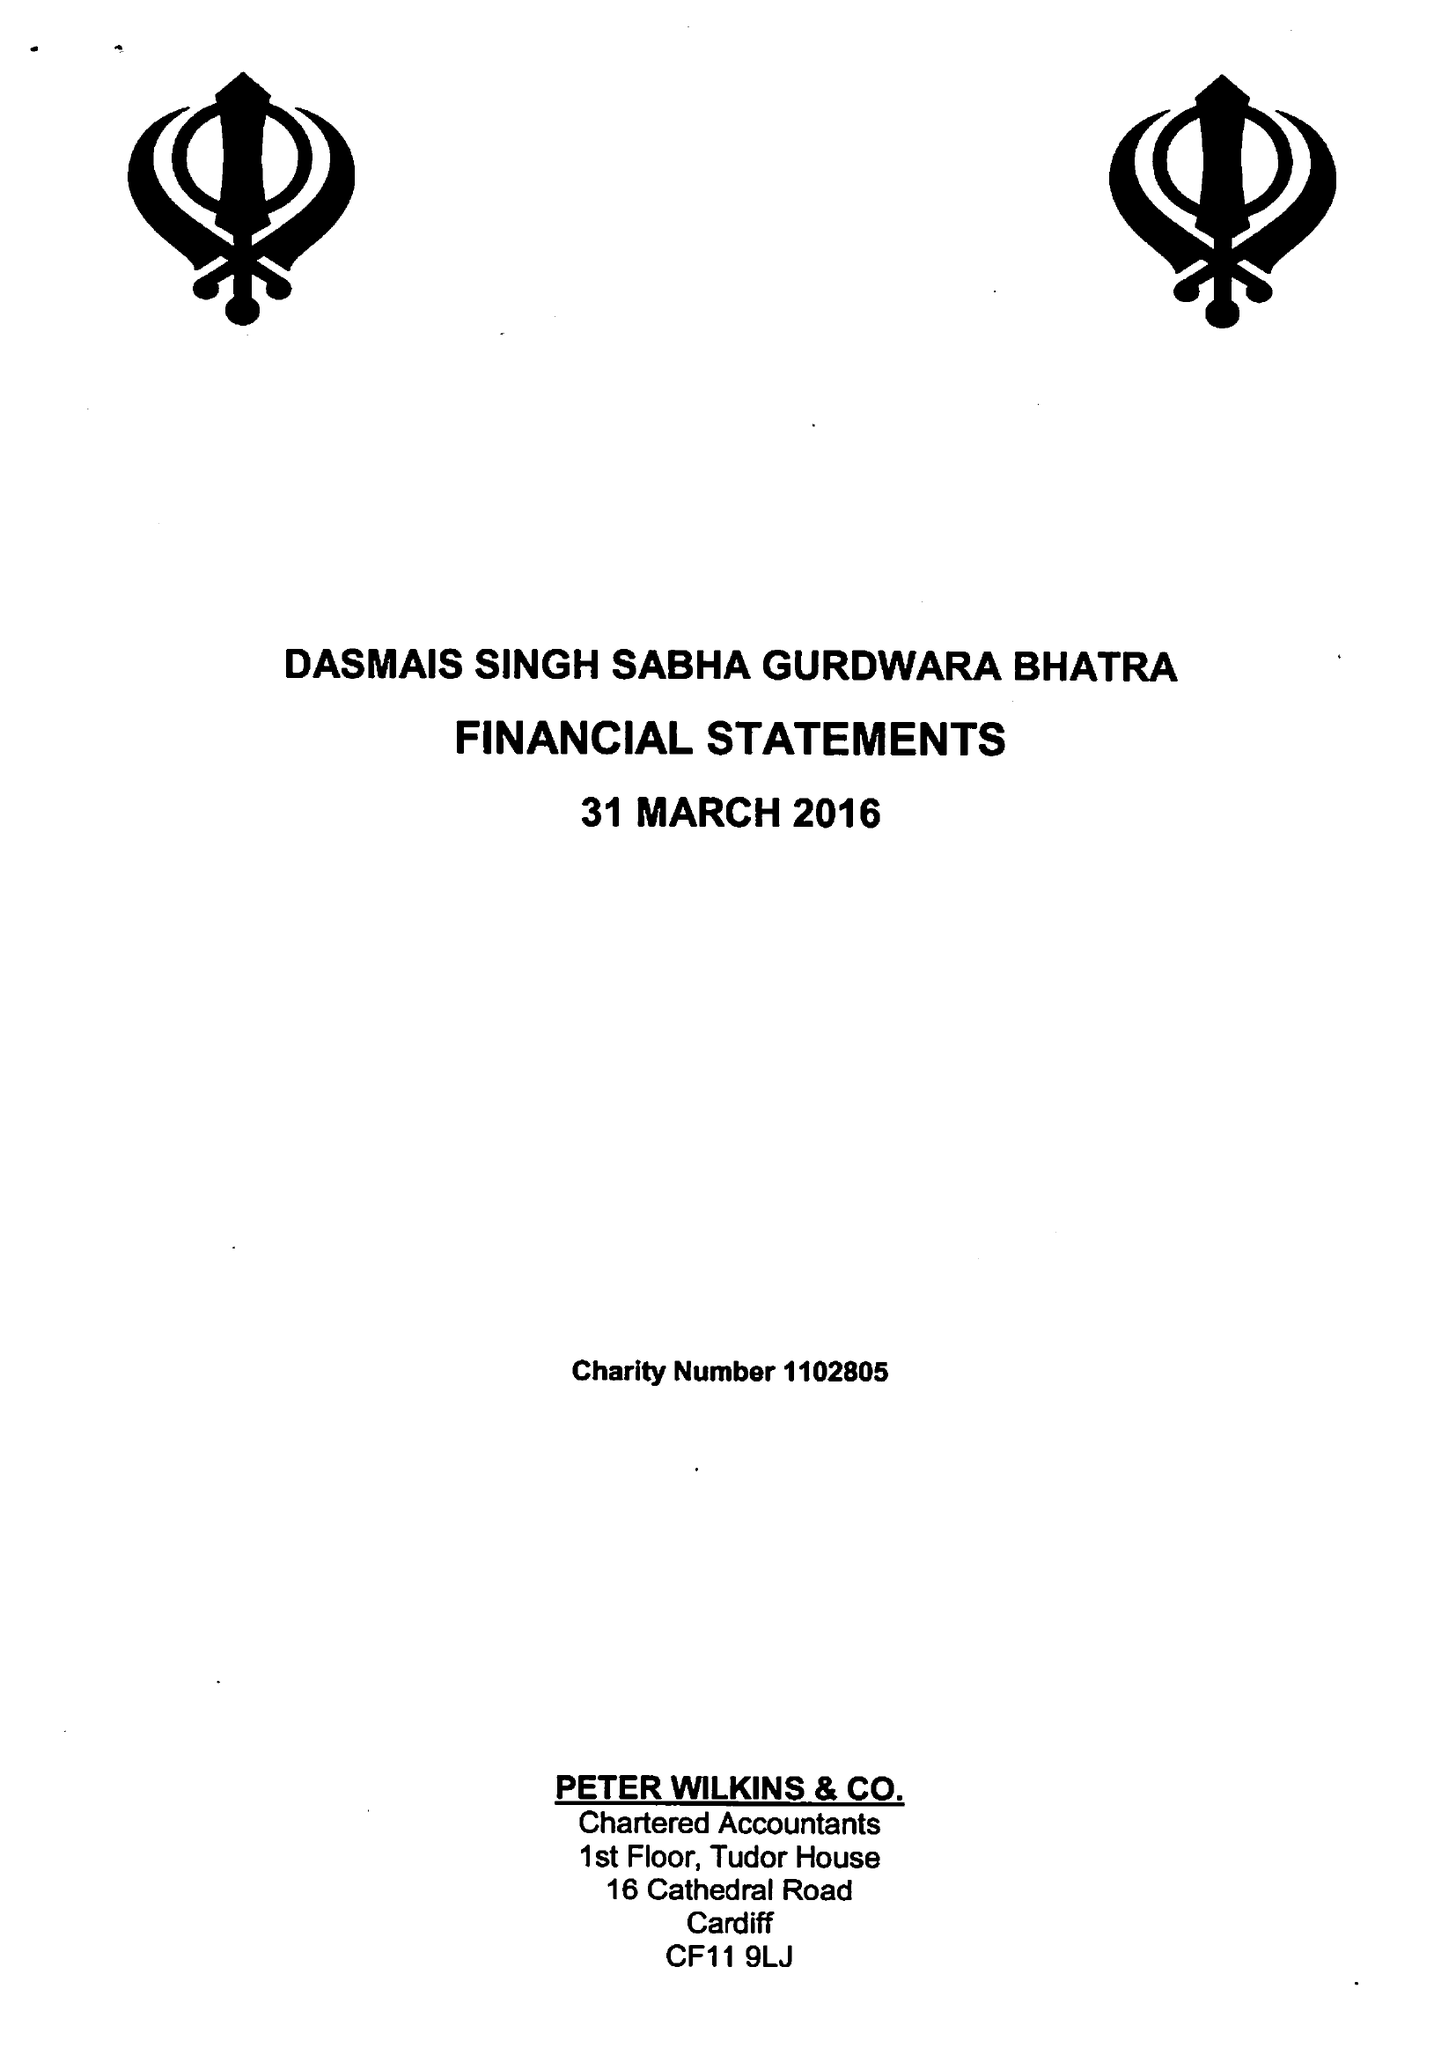What is the value for the address__post_town?
Answer the question using a single word or phrase. CARDIFF 